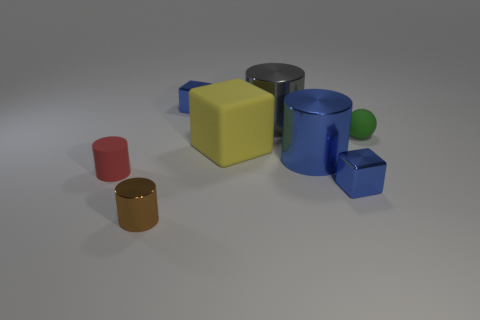How many things are either large yellow cubes or things that are to the left of the tiny green matte object?
Ensure brevity in your answer.  7. Is there a cylinder of the same color as the small matte sphere?
Your answer should be very brief. No. What number of green things are tiny rubber balls or big objects?
Your answer should be compact. 1. How many other things are the same size as the yellow rubber cube?
Offer a very short reply. 2. How many tiny things are either green rubber things or red shiny cubes?
Keep it short and to the point. 1. There is a yellow thing; is it the same size as the blue block that is in front of the small red matte cylinder?
Keep it short and to the point. No. How many other objects are there of the same shape as the green rubber object?
Give a very brief answer. 0. What is the shape of the green thing that is made of the same material as the big block?
Offer a very short reply. Sphere. Are there any big brown matte spheres?
Your answer should be very brief. No. Is the number of small cylinders to the right of the red rubber thing less than the number of yellow objects behind the big matte cube?
Keep it short and to the point. No. 